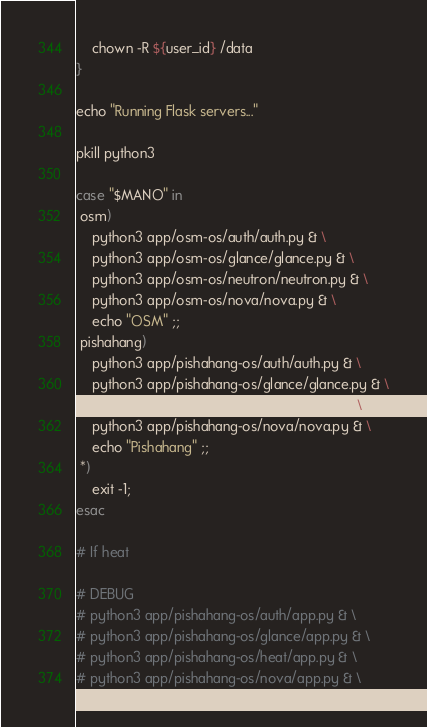Convert code to text. <code><loc_0><loc_0><loc_500><loc_500><_Bash_>    chown -R ${user_id} /data
}

echo "Running Flask servers..."

pkill python3

case "$MANO" in
 osm) 
    python3 app/osm-os/auth/auth.py & \
    python3 app/osm-os/glance/glance.py & \
    python3 app/osm-os/neutron/neutron.py & \
    python3 app/osm-os/nova/nova.py & \
    echo "OSM" ;;
 pishahang) 
    python3 app/pishahang-os/auth/auth.py & \
    python3 app/pishahang-os/glance/glance.py & \
    python3 app/pishahang-os/heat/heat.py & \
    python3 app/pishahang-os/nova/nova.py & \
    echo "Pishahang" ;;
 *) 
    exit -1;
esac

# If heat

# DEBUG
# python3 app/pishahang-os/auth/app.py & \
# python3 app/pishahang-os/glance/app.py & \
# python3 app/pishahang-os/heat/app.py & \
# python3 app/pishahang-os/nova/app.py & \
</code> 